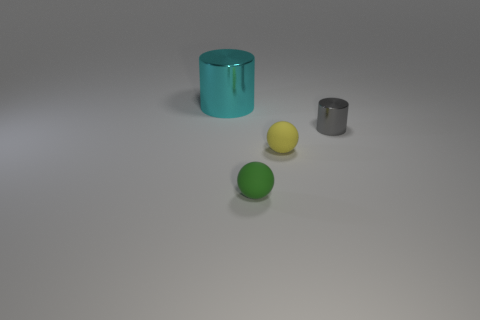Add 3 small shiny cylinders. How many objects exist? 7 Subtract 2 spheres. How many spheres are left? 0 Subtract all blue cylinders. How many green spheres are left? 1 Subtract all big cylinders. Subtract all small rubber spheres. How many objects are left? 1 Add 2 tiny green objects. How many tiny green objects are left? 3 Add 4 tiny things. How many tiny things exist? 7 Subtract 1 yellow balls. How many objects are left? 3 Subtract all cyan cylinders. Subtract all brown spheres. How many cylinders are left? 1 